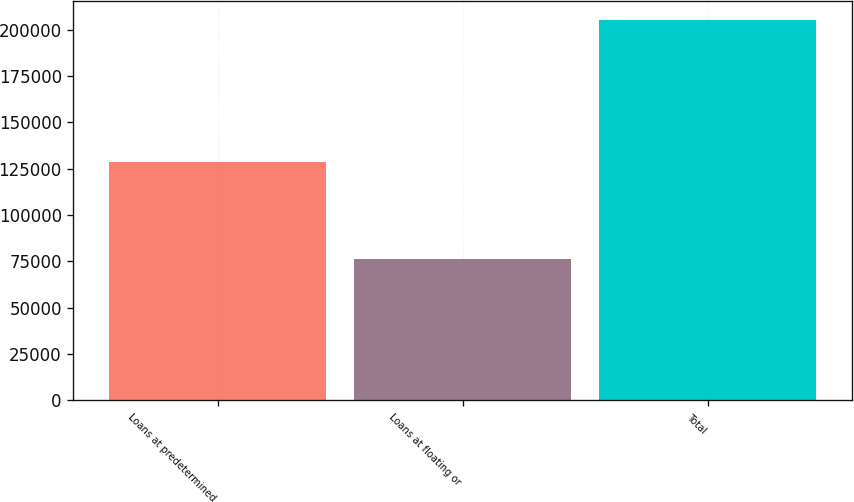Convert chart to OTSL. <chart><loc_0><loc_0><loc_500><loc_500><bar_chart><fcel>Loans at predetermined<fcel>Loans at floating or<fcel>Total<nl><fcel>128823<fcel>76407<fcel>205230<nl></chart> 